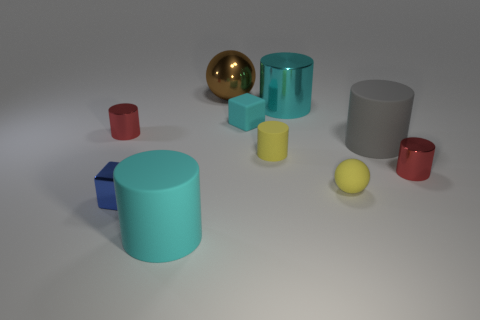Subtract all large cyan matte cylinders. How many cylinders are left? 5 Subtract all gray cylinders. How many cylinders are left? 5 Subtract all gray cylinders. Subtract all gray blocks. How many cylinders are left? 5 Subtract all cubes. How many objects are left? 8 Add 2 rubber cylinders. How many rubber cylinders exist? 5 Subtract 0 cyan balls. How many objects are left? 10 Subtract all yellow rubber cylinders. Subtract all gray cylinders. How many objects are left? 8 Add 4 gray rubber things. How many gray rubber things are left? 5 